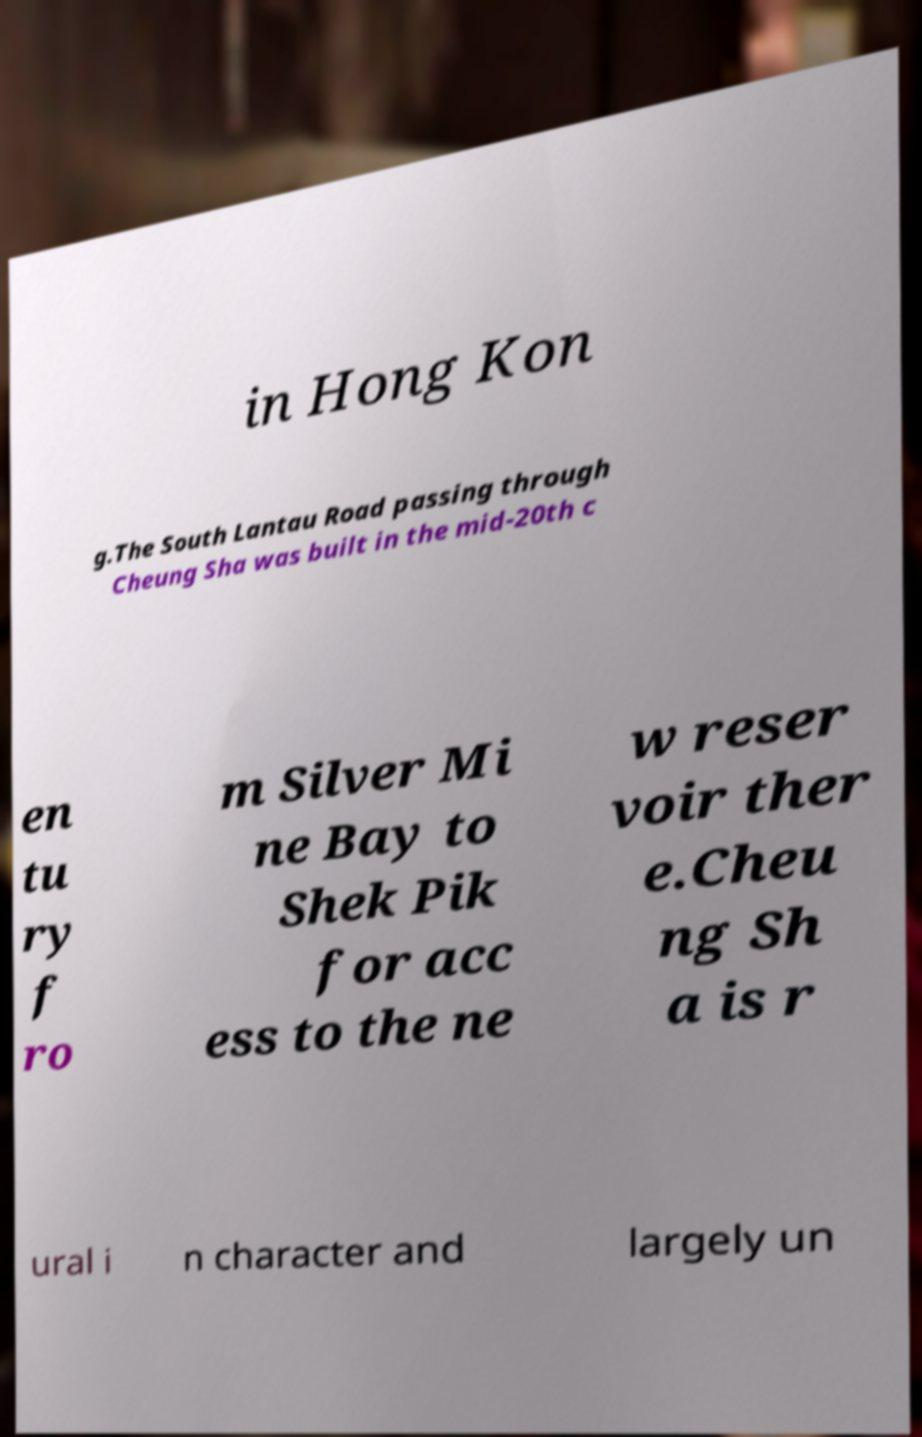I need the written content from this picture converted into text. Can you do that? in Hong Kon g.The South Lantau Road passing through Cheung Sha was built in the mid-20th c en tu ry f ro m Silver Mi ne Bay to Shek Pik for acc ess to the ne w reser voir ther e.Cheu ng Sh a is r ural i n character and largely un 